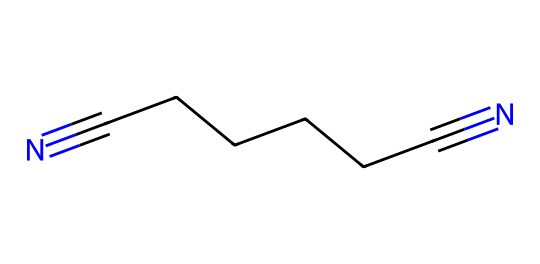What is the molecular formula of adiponitrile? To derive the molecular formula from the SMILES representation (N#CCCCCC#N), count the atoms represented. The "N" indicates nitrogen, and the "C" indicates carbon. There are 2 nitrogen atoms and 6 carbon atoms. Each carbon is bonded to adjacent carbons in a straight chain. Therefore, the molecular formula is C6H8N2, which includes the implicit hydrogen atoms necessary to satisfy carbon's tetravalency.
Answer: C6H8N2 How many carbon atoms are in adiponitrile? From the SMILES representation, there are six carbon atoms ('C'). This can be counted directly within the chain structure represented in the SMILES notation.
Answer: 6 What type of functional groups are present in adiponitrile? The chemical includes nitrile groups indicated by 'N#...' at each end of the carbon chain. The presence of these functional groups (–C≡N) suggests that it is a nitrile compound, prominently featuring the triple bond between carbon and nitrogen.
Answer: nitrile What is the degree of unsaturation in adiponitrile? To determine the degree of unsaturation, use the formula: unsaturation = (number of rings + number of double bonds + number of triple bonds)/2. The triple bonds present are counted as one degree of unsaturation each. In the case of adiponitrile, there are two triple bonds (one at each end), indicating a degree of unsaturation of 2.
Answer: 2 What is the significance of adiponitrile in Nylon production? Adiponitrile is critical as an intermediate in the synthesis of nylon, particularly nylon 6,6. It serves as a precursor that undergoes polymerization to create the polymer chains needed for nylon’s structure. This function illustrates its importance in producing synthetic fibers and high-strength materials.
Answer: precursor Does adiponitrile have any notable physical properties? Nitrile compounds generally have high boiling points due to the presence of polar functions and significant intermolecular interactions. Adiponitrile possesses characteristics typical of nitriles, such as being colorless and liquid at room temperature while having a specific boiling point. The boiling point can be outlined as a notable property.
Answer: colorless liquid 